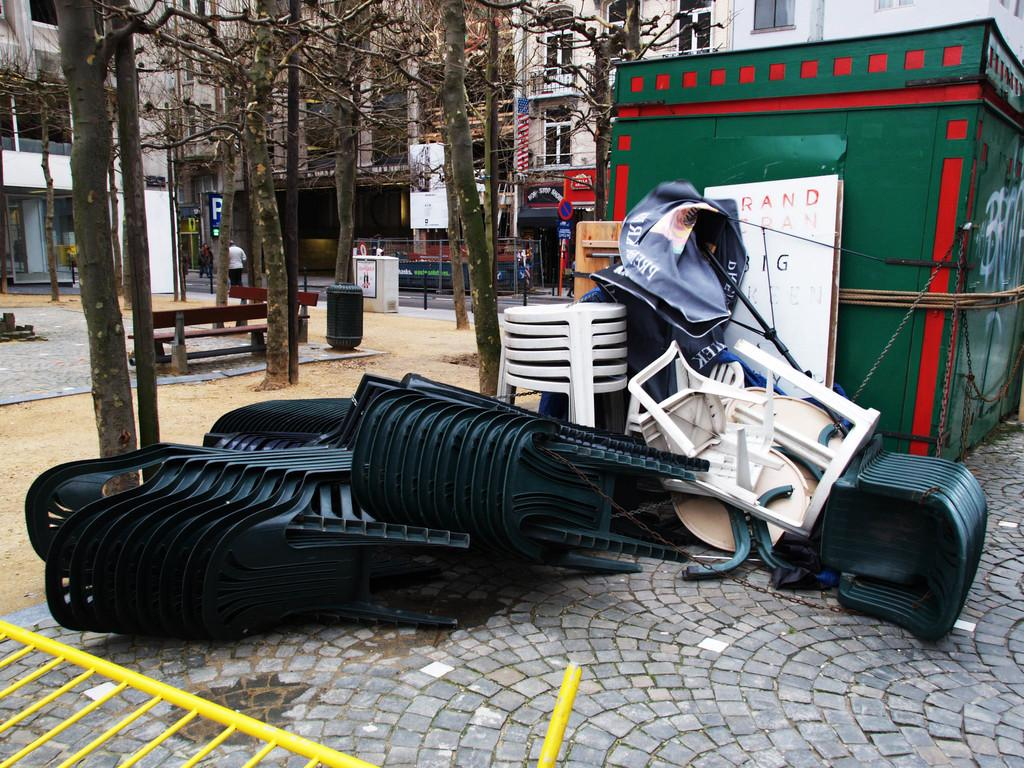How many chairs are visible in the image? There are many chairs in the image. Where are the chairs located? The chairs are kept on the floor. What can be seen on the floor in the image? There is a floor visible in the image. What is visible in the background of the image? There are buildings and trees in the background of the image. What structure is located on the right side of the image? There is a cabin on the right side of the image. What type of land is represented by the chairs in the image? The chairs do not represent any type of land; they are simply chairs placed on the floor. How does the image affect the viewer's mind? The image does not directly affect the viewer's mind; it is simply a visual representation of the scene. 